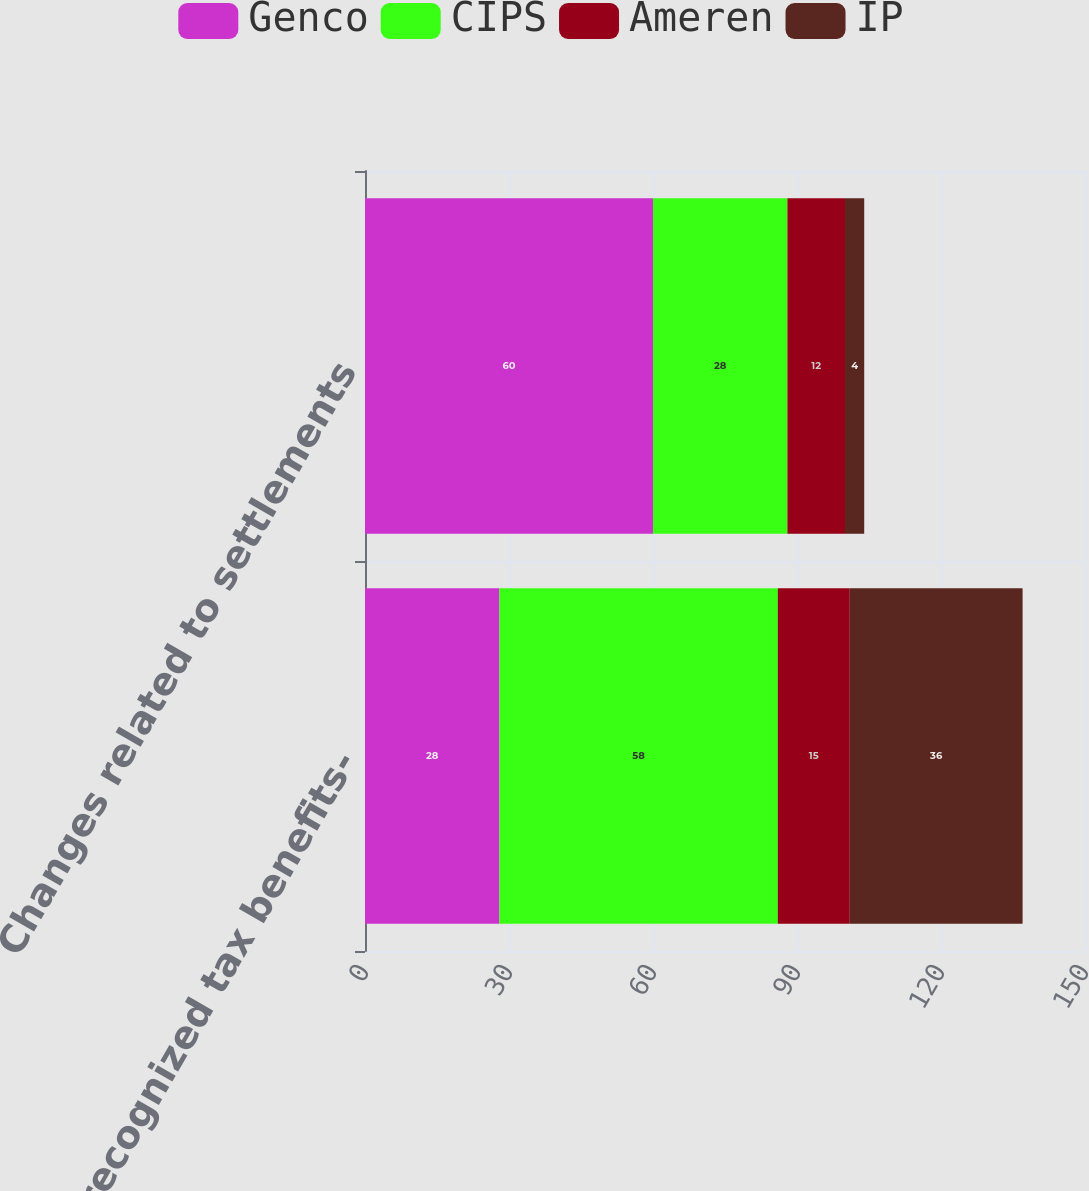Convert chart to OTSL. <chart><loc_0><loc_0><loc_500><loc_500><stacked_bar_chart><ecel><fcel>Unrecognized tax benefits-<fcel>Changes related to settlements<nl><fcel>Genco<fcel>28<fcel>60<nl><fcel>CIPS<fcel>58<fcel>28<nl><fcel>Ameren<fcel>15<fcel>12<nl><fcel>IP<fcel>36<fcel>4<nl></chart> 